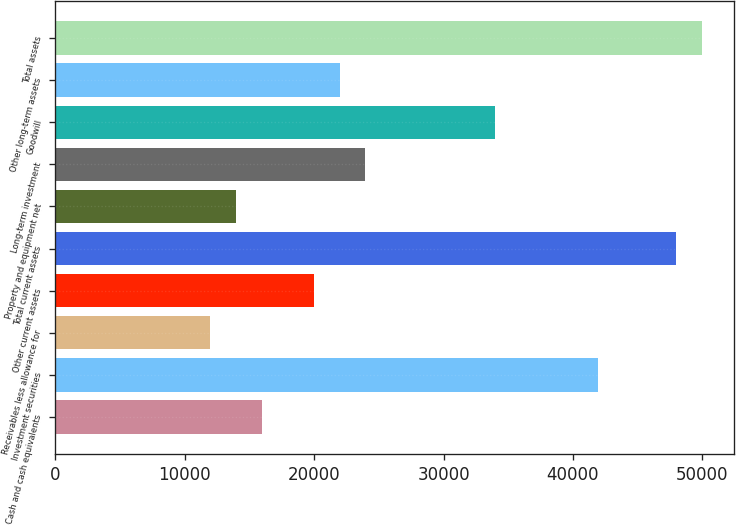Convert chart to OTSL. <chart><loc_0><loc_0><loc_500><loc_500><bar_chart><fcel>Cash and cash equivalents<fcel>Investment securities<fcel>Receivables less allowance for<fcel>Other current assets<fcel>Total current assets<fcel>Property and equipment net<fcel>Long-term investment<fcel>Goodwill<fcel>Other long-term assets<fcel>Total assets<nl><fcel>15983.8<fcel>41952.7<fcel>11988.6<fcel>19979<fcel>47945.6<fcel>13986.2<fcel>23974.2<fcel>33962.3<fcel>21976.6<fcel>49943.2<nl></chart> 